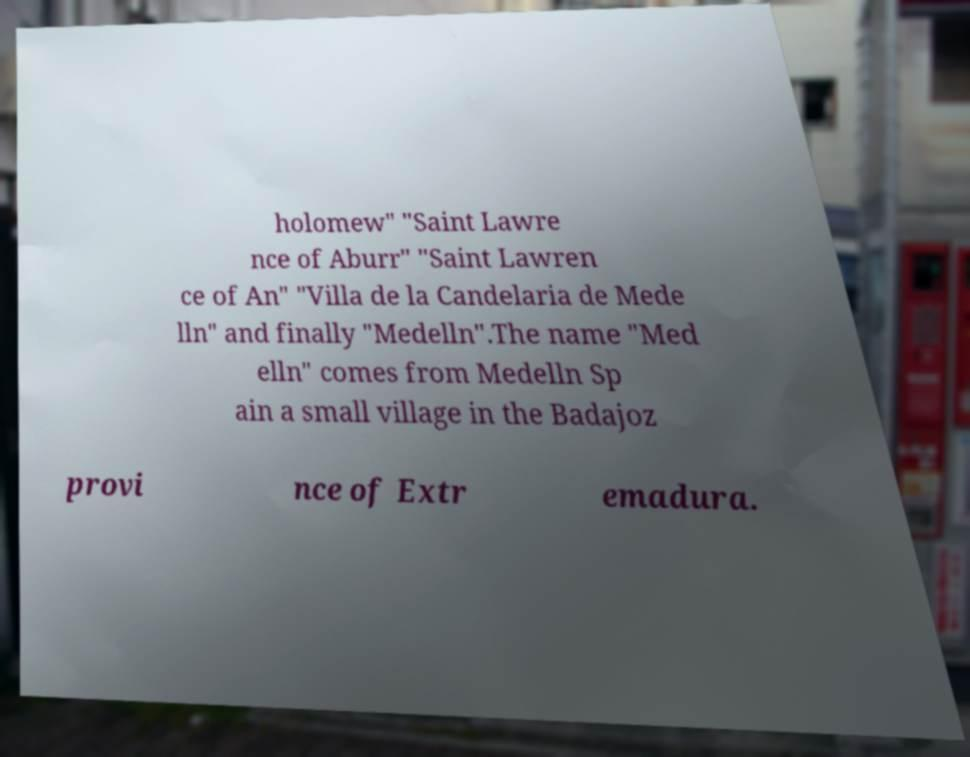I need the written content from this picture converted into text. Can you do that? holomew" "Saint Lawre nce of Aburr" "Saint Lawren ce of An" "Villa de la Candelaria de Mede lln" and finally "Medelln".The name "Med elln" comes from Medelln Sp ain a small village in the Badajoz provi nce of Extr emadura. 